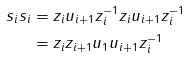Convert formula to latex. <formula><loc_0><loc_0><loc_500><loc_500>s _ { i } s _ { i } & = z _ { i } u _ { i + 1 } z _ { i } ^ { - 1 } z _ { i } u _ { i + 1 } z _ { i } ^ { - 1 } \\ & = z _ { i } z _ { i + 1 } u _ { 1 } u _ { i + 1 } z _ { i } ^ { - 1 }</formula> 